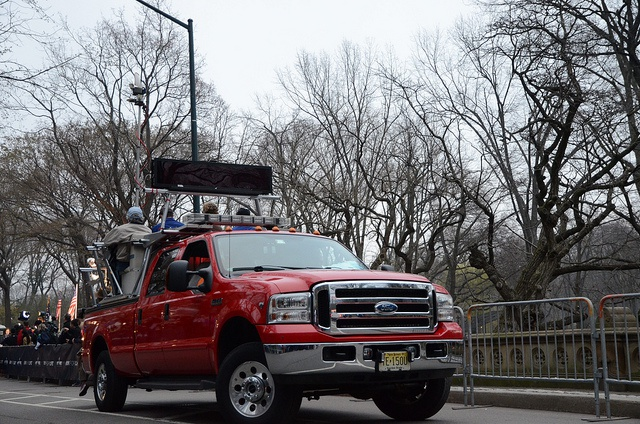Describe the objects in this image and their specific colors. I can see truck in lightgray, black, maroon, gray, and darkgray tones, traffic light in lightgray, black, gray, and darkgray tones, people in lightgray, black, gray, and darkgray tones, people in lightgray, black, gray, and maroon tones, and people in lightgray, navy, black, gray, and darkgray tones in this image. 